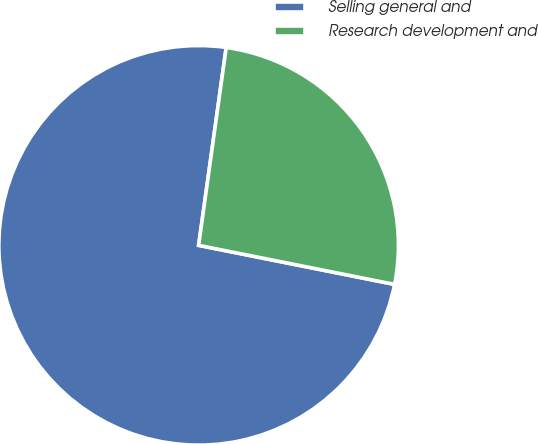Convert chart. <chart><loc_0><loc_0><loc_500><loc_500><pie_chart><fcel>Selling general and<fcel>Research development and<nl><fcel>74.07%<fcel>25.93%<nl></chart> 